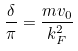Convert formula to latex. <formula><loc_0><loc_0><loc_500><loc_500>\frac { \delta } { \pi } = \frac { m v _ { 0 } } { k ^ { 2 } _ { F } }</formula> 